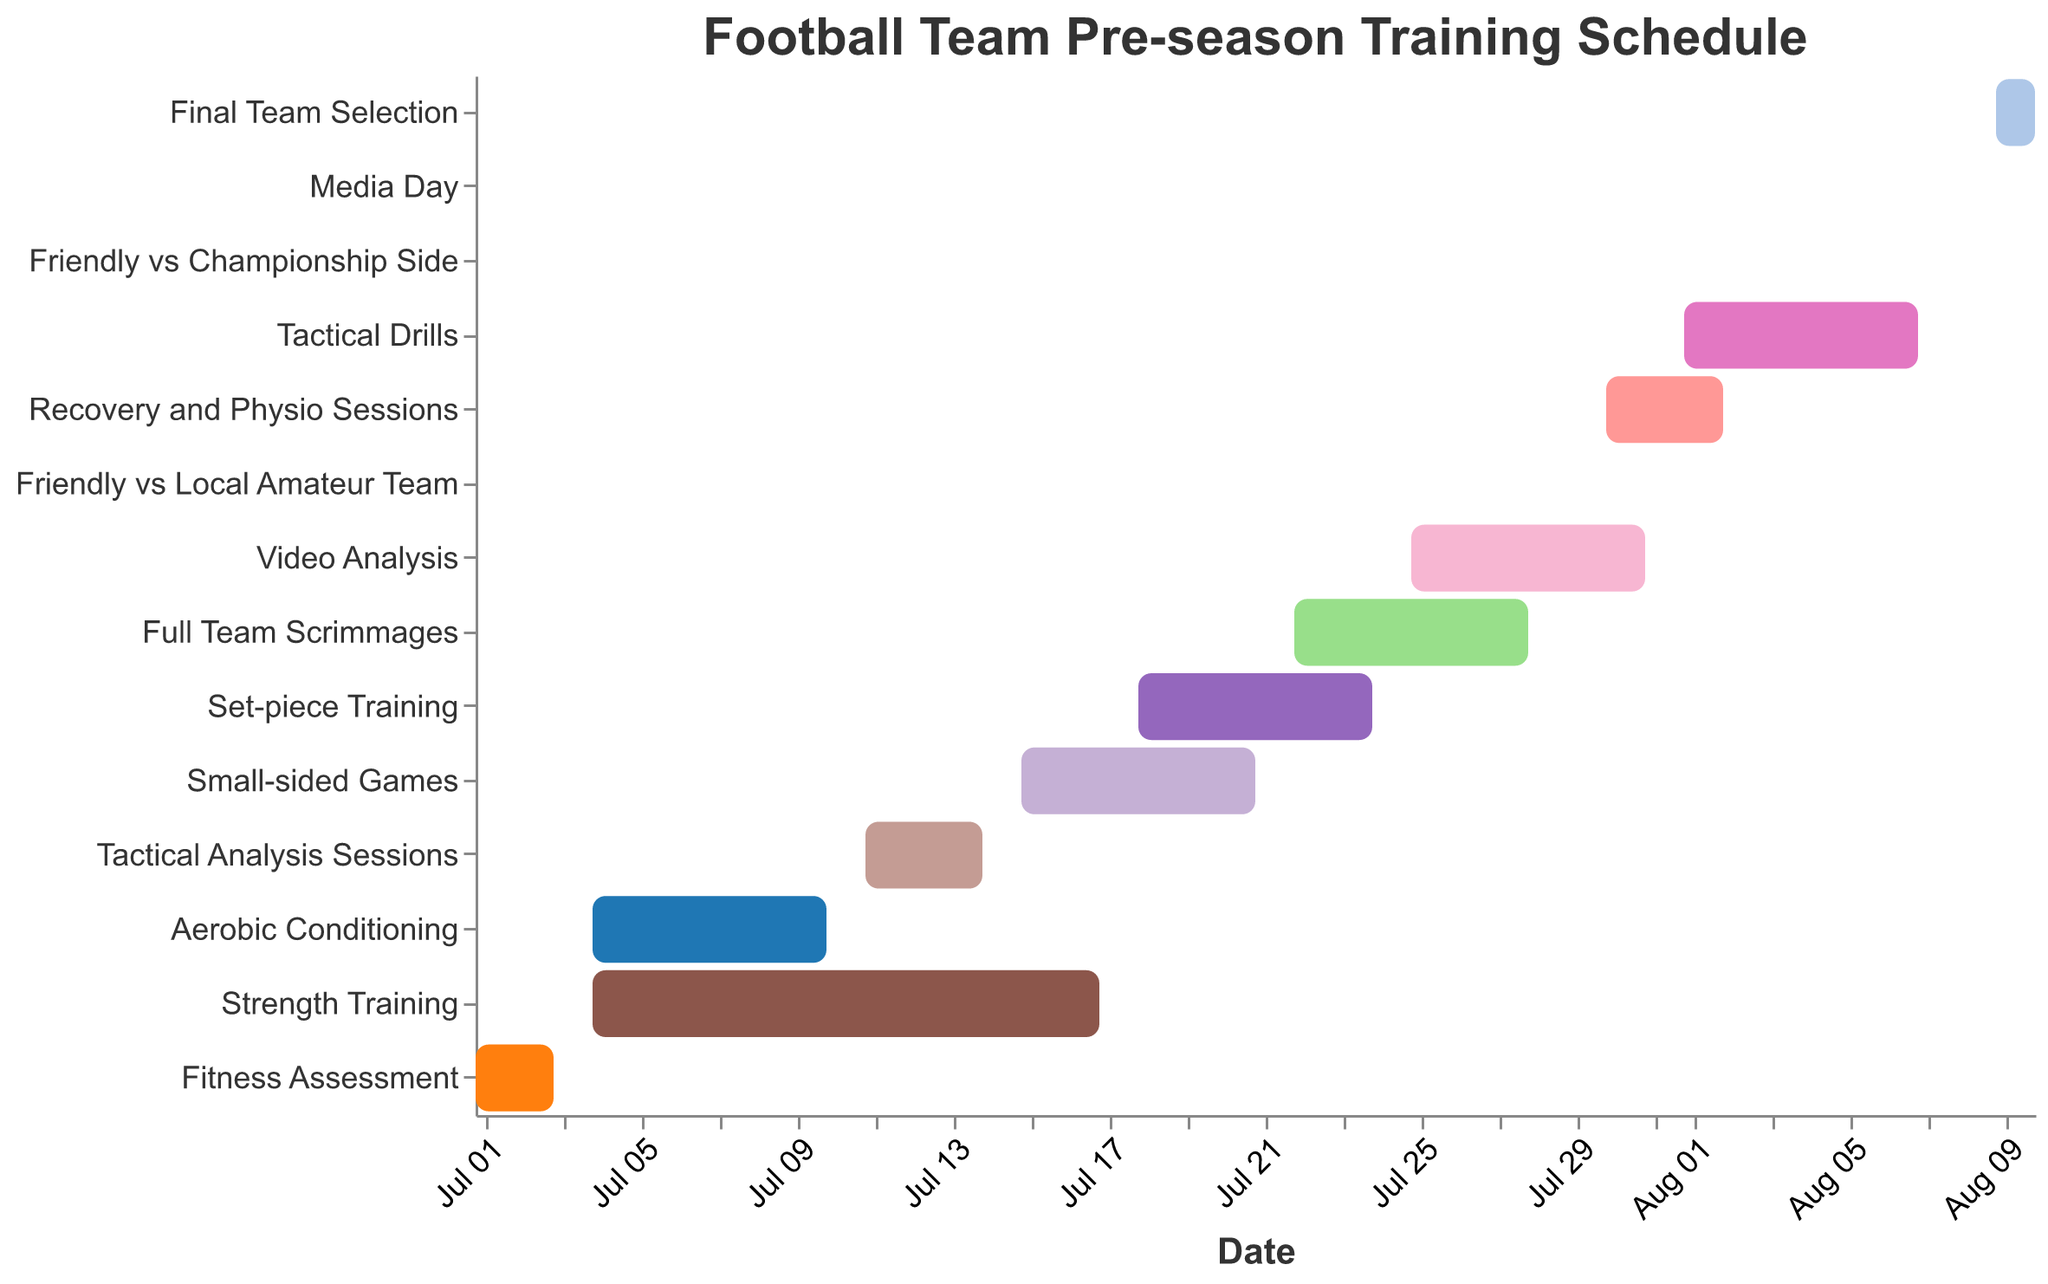What's the title of the Gantt chart? The title is positioned at the top of the figure, typically in larger font size than other text elements for emphasis. In this Gantt chart, the title is "Football Team Pre-season Training Schedule".
Answer: Football Team Pre-season Training Schedule How long is the Fitness Assessment period? The Fitness Assessment task starts on July 1 and ends on July 3. To find its duration, we calculate the number of days between the start and end dates: July 3 - July 1.
Answer: 3 days What tasks overlap with Strength Training? Referring to the Gantt chart, Strength Training runs from July 4 to July 17. The overlapping tasks are Aerobic Conditioning which runs from July 4 to July 10 and Tactical Analysis Sessions which runs from July 11 to July 14.
Answer: Aerobic Conditioning, Tactical Analysis Sessions Which tasks are scheduled to be completed by the end of July? To find this, we identify tasks that have an end date on or before July 31: Fitness Assessment, Aerobic Conditioning, Strength Training, Tactical Analysis Sessions, Small-sided Games, Set-piece Training, Full Team Scrimmages, Video Analysis, Friendly vs Local Amateur Team, and Recovery and Physio Sessions.
Answer: Fitness Assessment, Aerobic Conditioning, Strength Training, Tactical Analysis Sessions, Small-sided Games, Set-piece Training, Full Team Scrimmages, Video Analysis, Friendly vs Local Amateur Team, Recovery and Physio Sessions What task has the shortest duration, and how long is it? By examining the Gantt chart, the task "Friendly vs Local Amateur Team" is completed in a single day on July 29, and "Friendly vs Championship Side" on August 5 also spans just one day.
Answer: Friendly vs Local Amateur Team, Friendly vs Championship Side - 1 day each During which period do Small-sided Games and Set-piece Training overlap? Small-sided Games run from July 15 to July 21, and Set-piece Training runs from July 18 to July 24. The overlapping period between these tasks is from July 18 to July 21.
Answer: July 18 to July 21 What is the gap between Friendly vs Local Amateur Team and Friendly vs Championship Side? The Friendly vs Local Amateur Team is scheduled for July 29, and the Friendly vs Championship Side is on August 5. The gap between these dates is August 5 - July 29, which equals 7 days.
Answer: 7 days Which period exclusively focuses on Tactical activities? Tactical Analysis Sessions (July 11 to July 14), followed by Tactical Drills (August 1 to August 7) are exclusively tactical activities, but the period between July 11 and July 14 is specifically focused on tactics alone without coinciding training sessions.
Answer: July 11 to July 14 